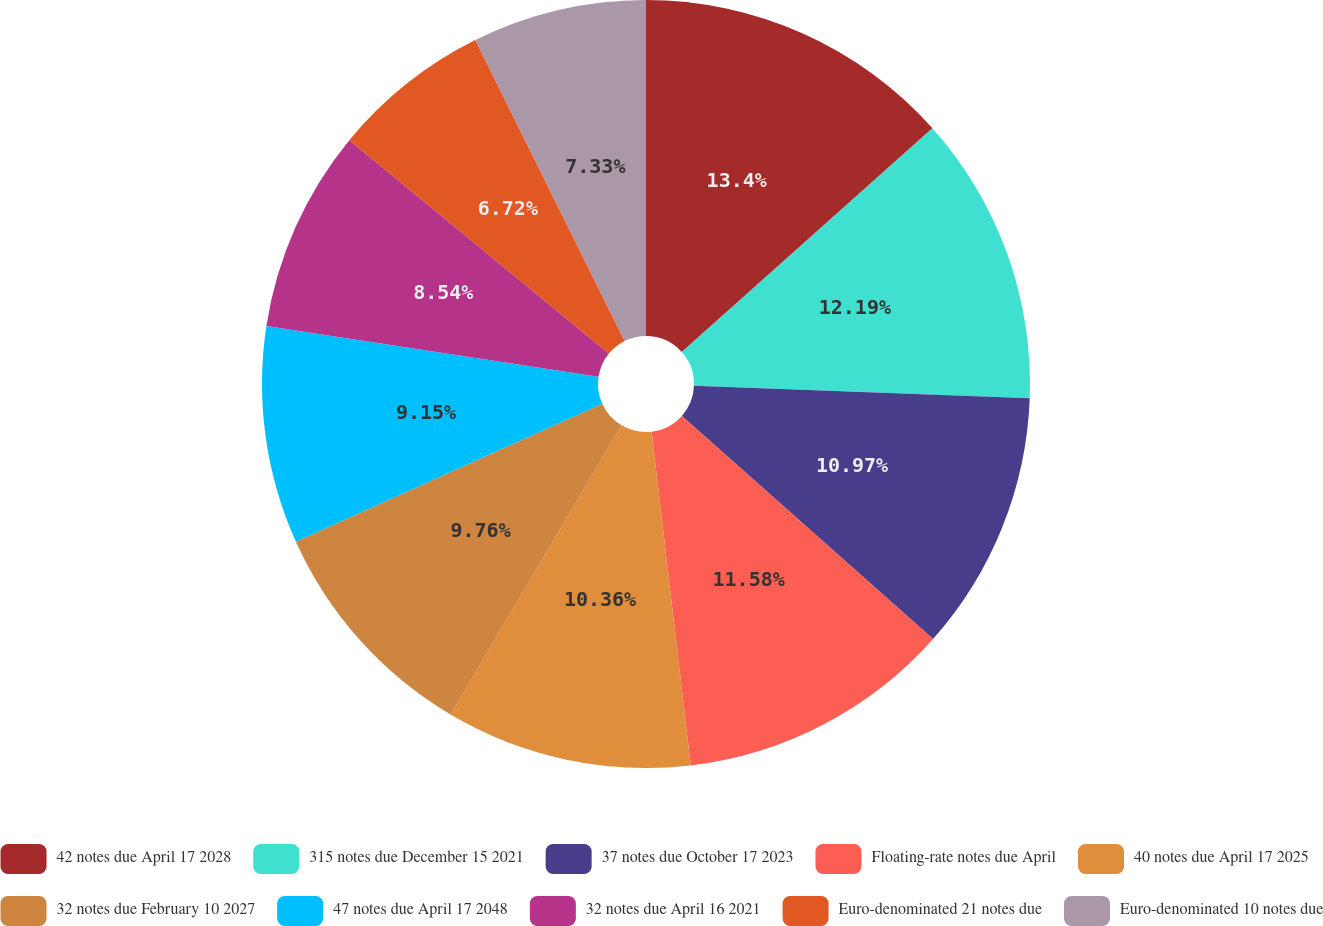Convert chart. <chart><loc_0><loc_0><loc_500><loc_500><pie_chart><fcel>42 notes due April 17 2028<fcel>315 notes due December 15 2021<fcel>37 notes due October 17 2023<fcel>Floating-rate notes due April<fcel>40 notes due April 17 2025<fcel>32 notes due February 10 2027<fcel>47 notes due April 17 2048<fcel>32 notes due April 16 2021<fcel>Euro-denominated 21 notes due<fcel>Euro-denominated 10 notes due<nl><fcel>13.4%<fcel>12.19%<fcel>10.97%<fcel>11.58%<fcel>10.36%<fcel>9.76%<fcel>9.15%<fcel>8.54%<fcel>6.72%<fcel>7.33%<nl></chart> 